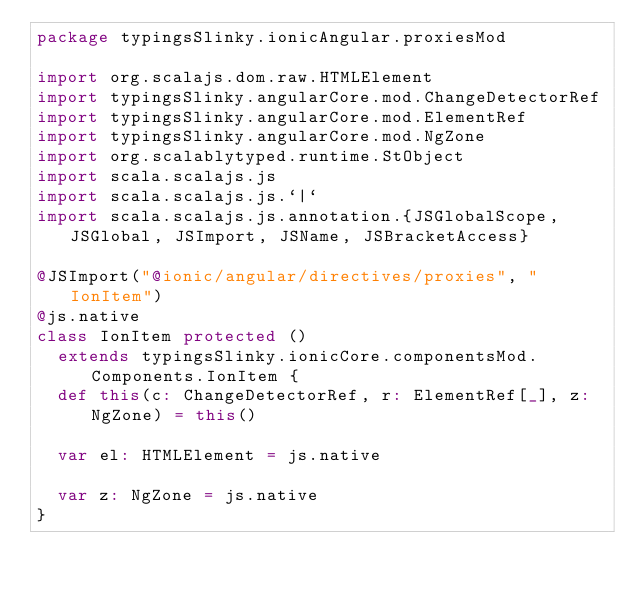<code> <loc_0><loc_0><loc_500><loc_500><_Scala_>package typingsSlinky.ionicAngular.proxiesMod

import org.scalajs.dom.raw.HTMLElement
import typingsSlinky.angularCore.mod.ChangeDetectorRef
import typingsSlinky.angularCore.mod.ElementRef
import typingsSlinky.angularCore.mod.NgZone
import org.scalablytyped.runtime.StObject
import scala.scalajs.js
import scala.scalajs.js.`|`
import scala.scalajs.js.annotation.{JSGlobalScope, JSGlobal, JSImport, JSName, JSBracketAccess}

@JSImport("@ionic/angular/directives/proxies", "IonItem")
@js.native
class IonItem protected ()
  extends typingsSlinky.ionicCore.componentsMod.Components.IonItem {
  def this(c: ChangeDetectorRef, r: ElementRef[_], z: NgZone) = this()
  
  var el: HTMLElement = js.native
  
  var z: NgZone = js.native
}
</code> 